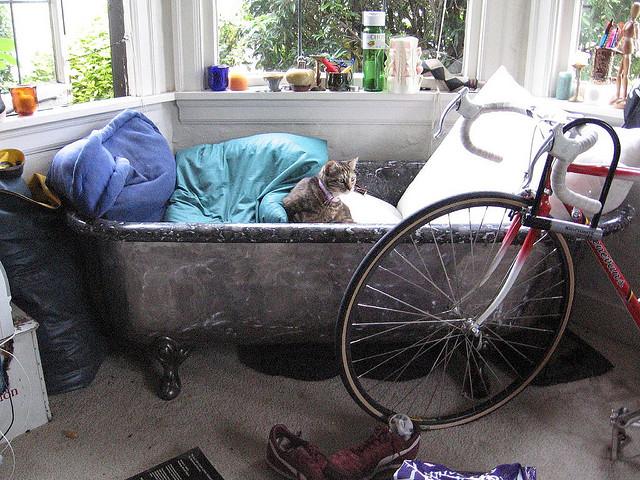How many bikes are present?
Be succinct. 1. Is the bathtub usable?
Keep it brief. No. Is the cat taking a bath?
Give a very brief answer. No. 